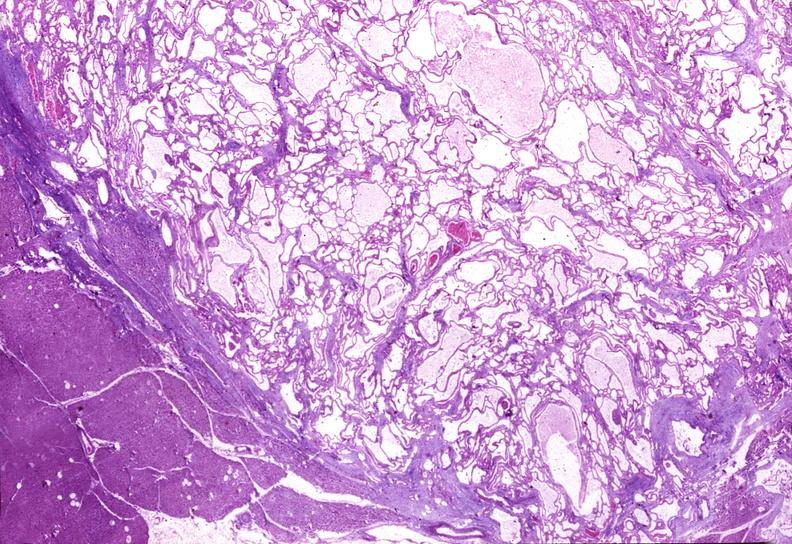does this image show cystadenoma?
Answer the question using a single word or phrase. Yes 